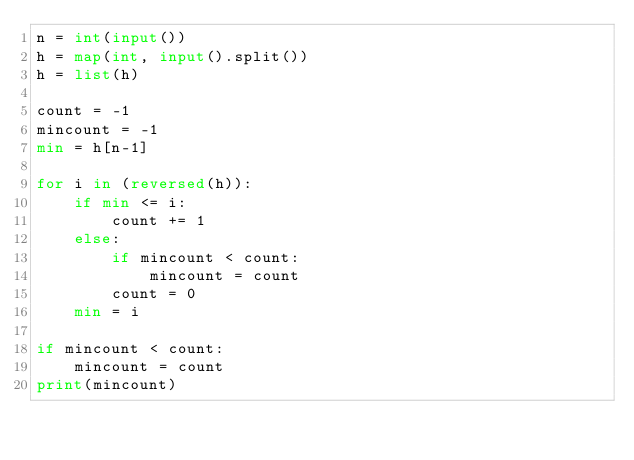<code> <loc_0><loc_0><loc_500><loc_500><_Python_>n = int(input())
h = map(int, input().split())
h = list(h)

count = -1
mincount = -1
min = h[n-1]

for i in (reversed(h)):
    if min <= i:
        count += 1
    else:
        if mincount < count:
            mincount = count
        count = 0
    min = i
        
if mincount < count:
    mincount = count
print(mincount)
</code> 